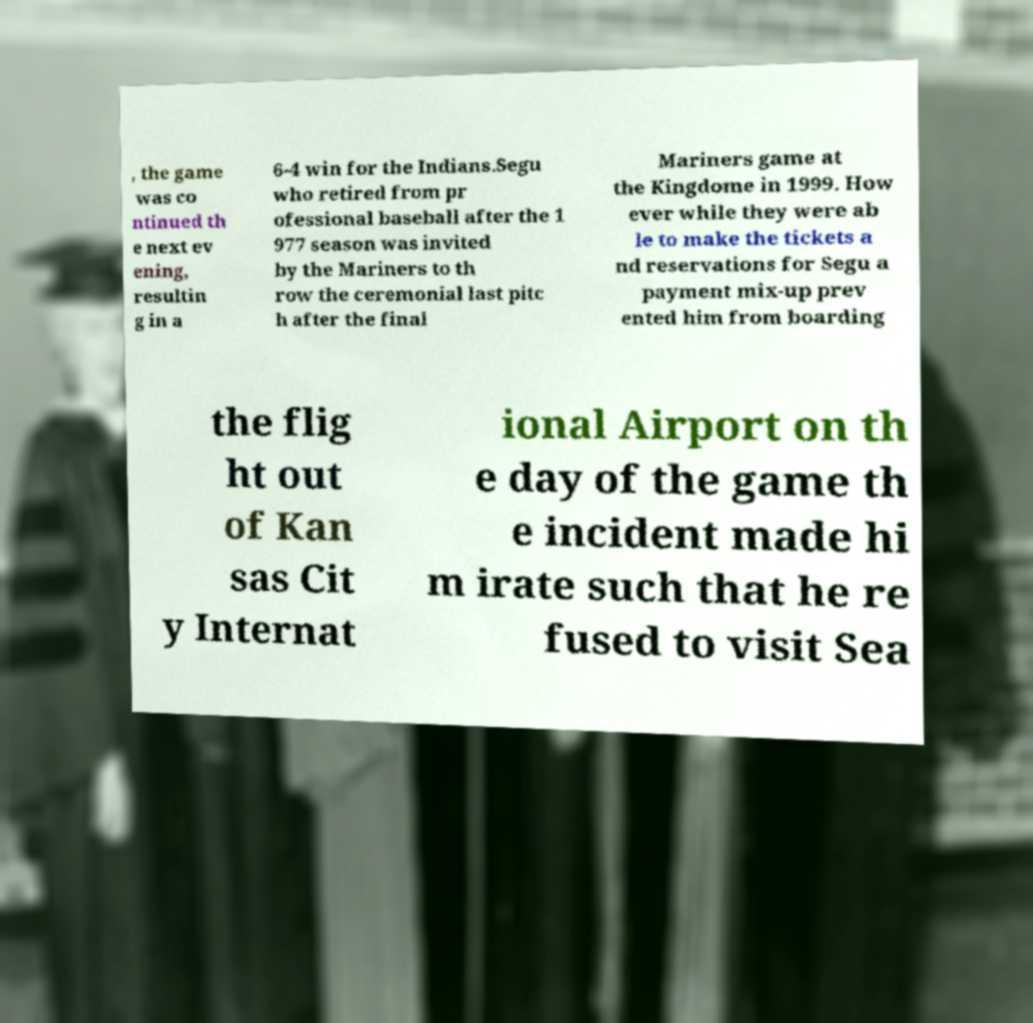Please read and relay the text visible in this image. What does it say? , the game was co ntinued th e next ev ening, resultin g in a 6-4 win for the Indians.Segu who retired from pr ofessional baseball after the 1 977 season was invited by the Mariners to th row the ceremonial last pitc h after the final Mariners game at the Kingdome in 1999. How ever while they were ab le to make the tickets a nd reservations for Segu a payment mix-up prev ented him from boarding the flig ht out of Kan sas Cit y Internat ional Airport on th e day of the game th e incident made hi m irate such that he re fused to visit Sea 